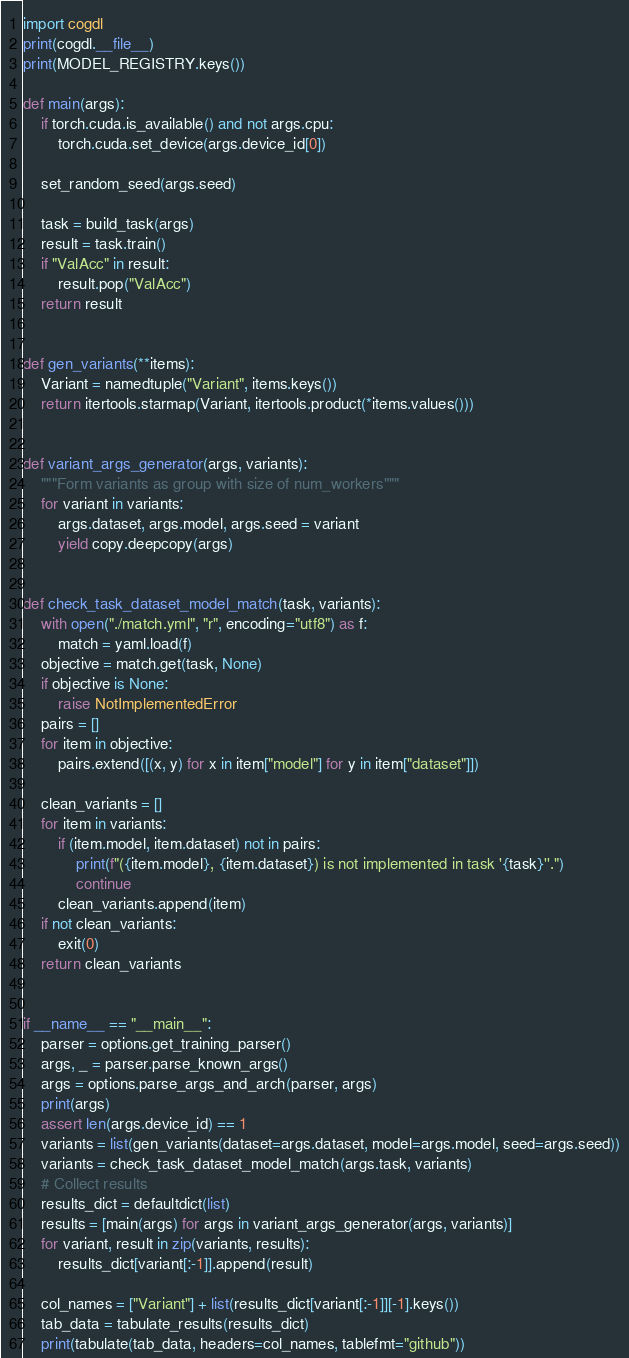Convert code to text. <code><loc_0><loc_0><loc_500><loc_500><_Python_>import cogdl
print(cogdl.__file__)
print(MODEL_REGISTRY.keys())

def main(args):
    if torch.cuda.is_available() and not args.cpu:
        torch.cuda.set_device(args.device_id[0])

    set_random_seed(args.seed)

    task = build_task(args)
    result = task.train()
    if "ValAcc" in result:
        result.pop("ValAcc")
    return result


def gen_variants(**items):
    Variant = namedtuple("Variant", items.keys())
    return itertools.starmap(Variant, itertools.product(*items.values()))


def variant_args_generator(args, variants):
    """Form variants as group with size of num_workers"""
    for variant in variants:
        args.dataset, args.model, args.seed = variant
        yield copy.deepcopy(args)


def check_task_dataset_model_match(task, variants):
    with open("./match.yml", "r", encoding="utf8") as f:
        match = yaml.load(f)
    objective = match.get(task, None)
    if objective is None:
        raise NotImplementedError
    pairs = []
    for item in objective:
        pairs.extend([(x, y) for x in item["model"] for y in item["dataset"]])

    clean_variants = []
    for item in variants:
        if (item.model, item.dataset) not in pairs:
            print(f"({item.model}, {item.dataset}) is not implemented in task '{task}''.")
            continue
        clean_variants.append(item)
    if not clean_variants:
        exit(0)
    return clean_variants


if __name__ == "__main__":
    parser = options.get_training_parser()
    args, _ = parser.parse_known_args()
    args = options.parse_args_and_arch(parser, args)
    print(args)
    assert len(args.device_id) == 1
    variants = list(gen_variants(dataset=args.dataset, model=args.model, seed=args.seed))
    variants = check_task_dataset_model_match(args.task, variants)
    # Collect results
    results_dict = defaultdict(list)
    results = [main(args) for args in variant_args_generator(args, variants)]
    for variant, result in zip(variants, results):
        results_dict[variant[:-1]].append(result)

    col_names = ["Variant"] + list(results_dict[variant[:-1]][-1].keys())
    tab_data = tabulate_results(results_dict)
    print(tabulate(tab_data, headers=col_names, tablefmt="github"))
</code> 